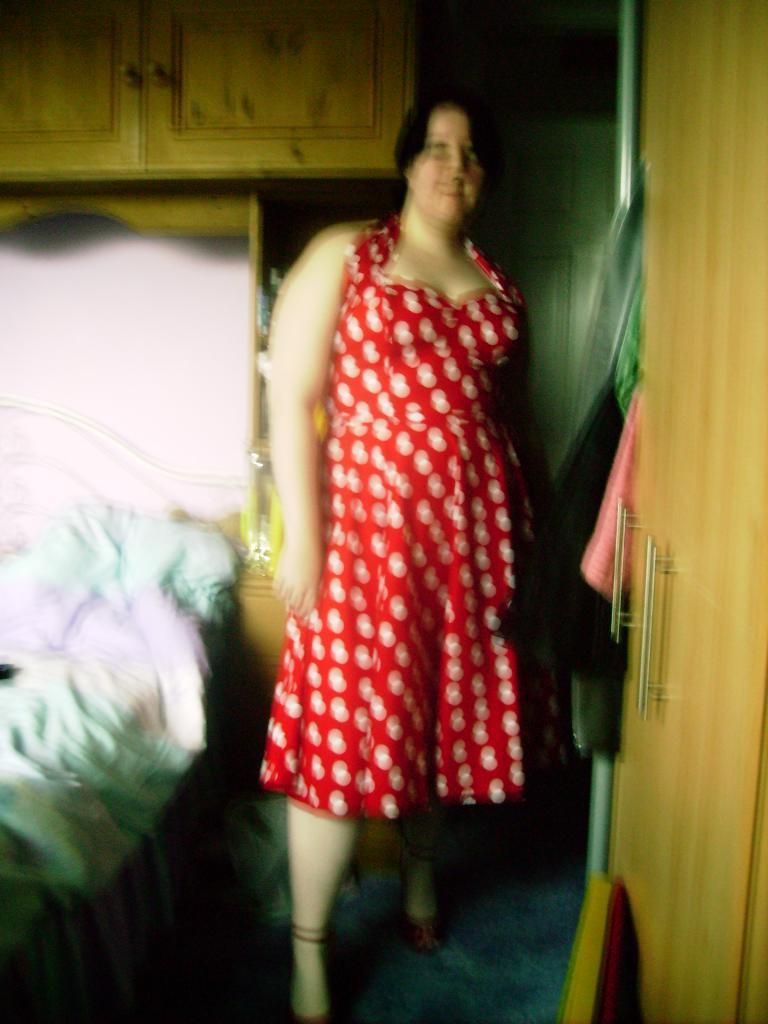What is the main subject in the image? There is a woman standing in the image. What objects can be seen on the sides of the image? There is a bed on the left side of the image and a door on the right side of the image. What is located in the back of the image? There is a cupboard in the back of the image. What type of powder is being used to decorate the cake in the image? There is no cake or powder present in the image. What is the woman's opinion on the cake in the image? There is no cake or indication of the woman's opinion in the image. 